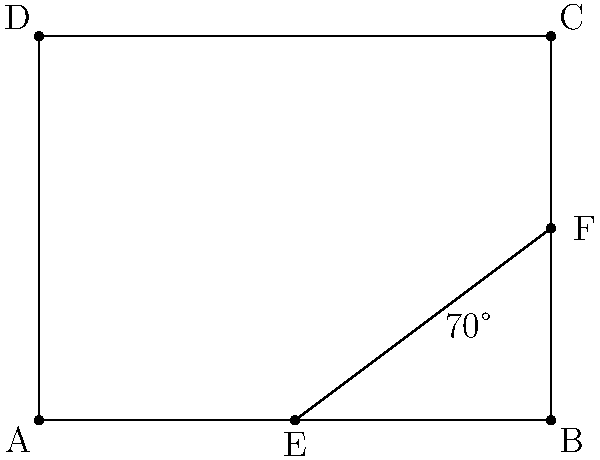In the mobile library, two intersecting bookshelf rows form a 70° angle. If the length of one row is 4 meters and the perpendicular distance from point E to the other row is 1.5 meters, what is the length of AE? Let's approach this step-by-step:

1) In the diagram, ABCD represents the library floor, and EF represents the intersecting bookshelf row.

2) We're given that angle BEF is 70°.

3) In the right triangle EFB:
   - The angle at B is 90° (perpendicular)
   - The angle at E is 70°
   - Therefore, the angle at F must be 20° (as angles in a triangle sum to 180°)

4) We're told that FB (the perpendicular distance) is 1.5 meters.

5) To find AE, we need to use the tangent function in the right triangle EFB:

   $\tan 20° = \frac{opposite}{adjacent} = \frac{FB}{EB} = \frac{1.5}{EB}$

6) Rearranging this equation:

   $EB = \frac{1.5}{\tan 20°}$

7) Using a calculator (or knowing the value of $\tan 20°$):

   $EB \approx 4.12$ meters

8) Since AB is 4 meters, AE is:

   $AE = AB - EB = 4 - 4.12 \approx -0.12$ meters

9) The negative value means E is actually slightly outside the rectangle ABCD.

10) The absolute value of this is the distance from A to E.
Answer: 0.12 meters 